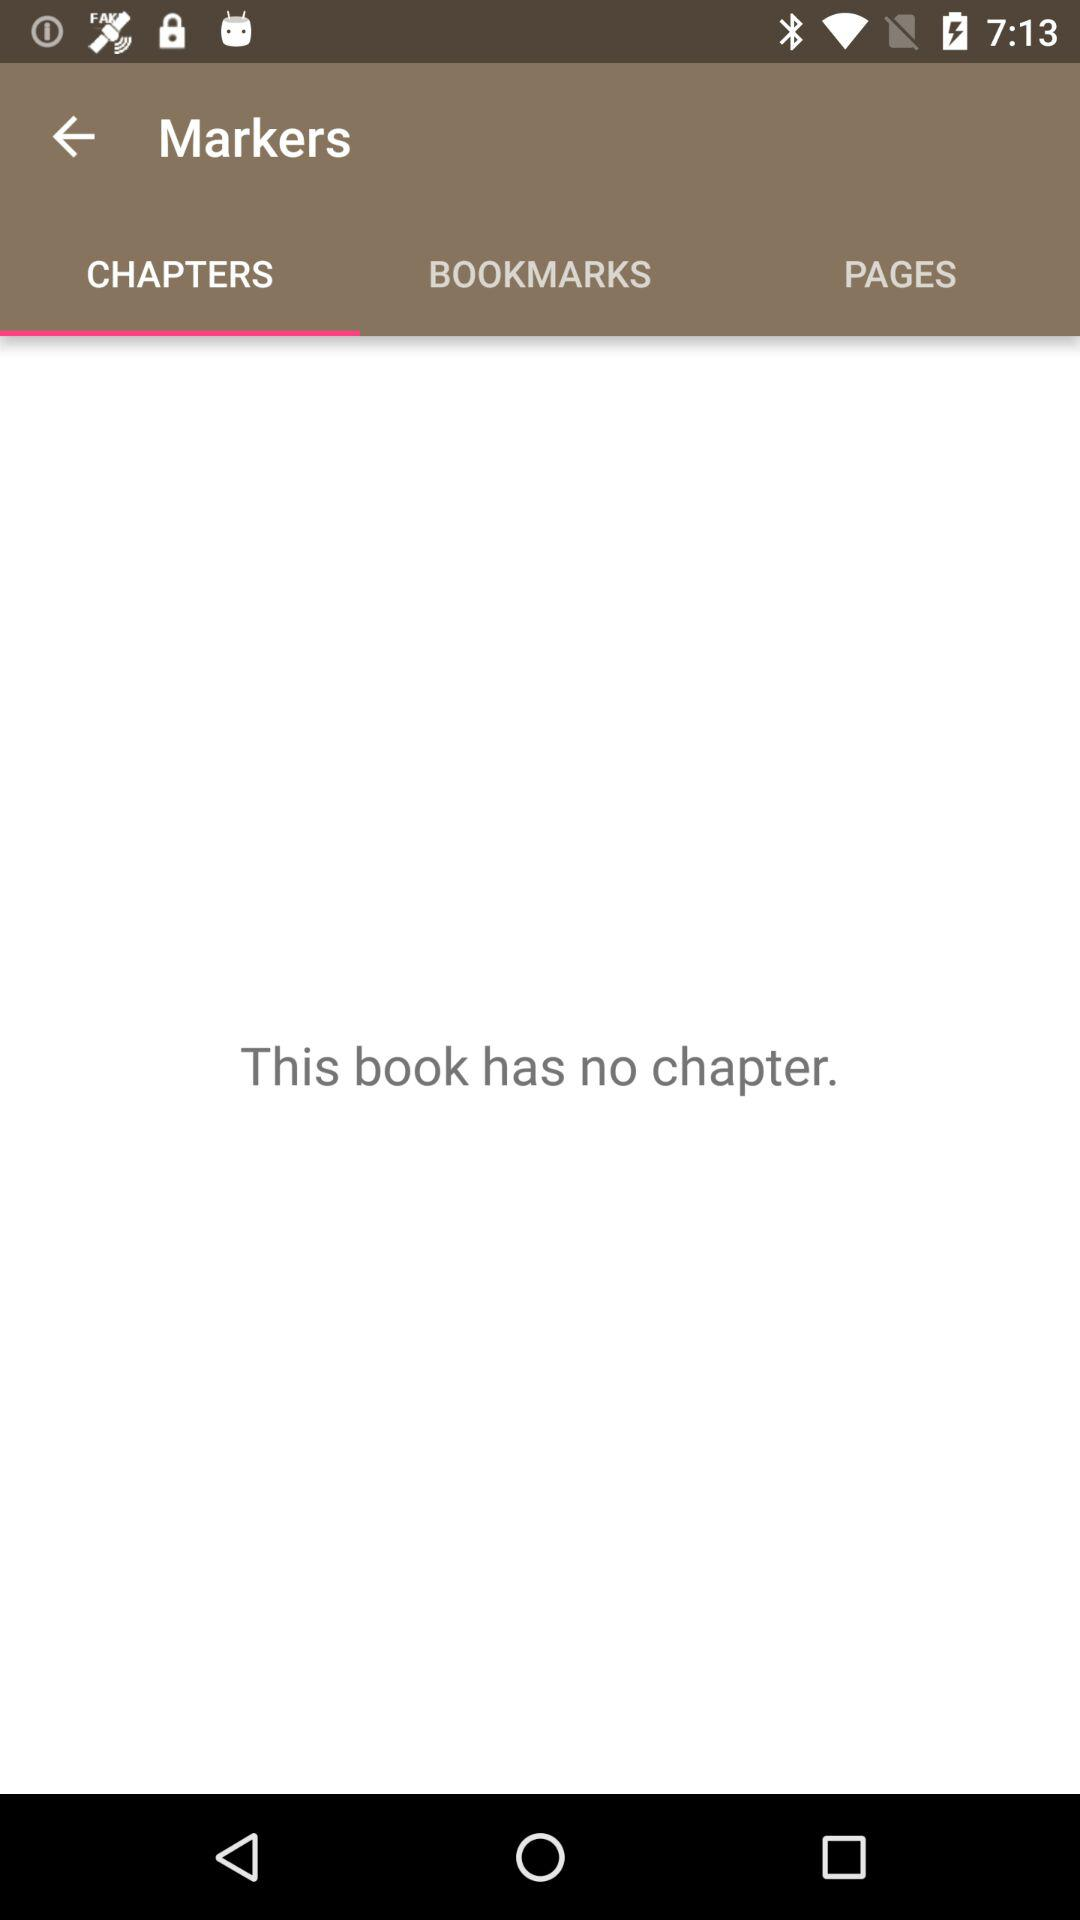Which tab of "Markers" am I on? You are on the "CHAPTERS" tab. 